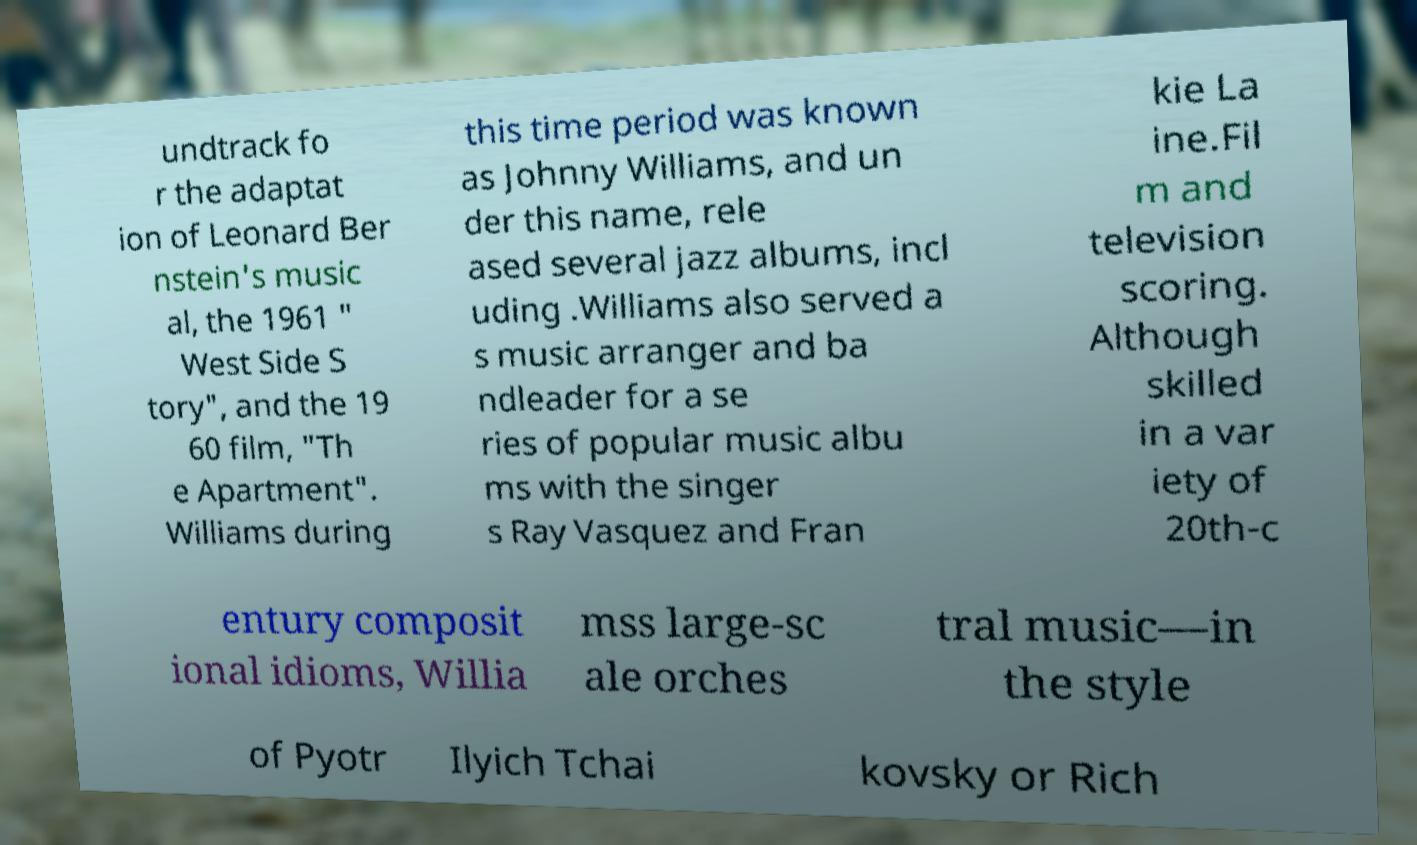There's text embedded in this image that I need extracted. Can you transcribe it verbatim? undtrack fo r the adaptat ion of Leonard Ber nstein's music al, the 1961 " West Side S tory", and the 19 60 film, "Th e Apartment". Williams during this time period was known as Johnny Williams, and un der this name, rele ased several jazz albums, incl uding .Williams also served a s music arranger and ba ndleader for a se ries of popular music albu ms with the singer s Ray Vasquez and Fran kie La ine.Fil m and television scoring. Although skilled in a var iety of 20th-c entury composit ional idioms, Willia mss large-sc ale orches tral music—in the style of Pyotr Ilyich Tchai kovsky or Rich 